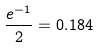Convert formula to latex. <formula><loc_0><loc_0><loc_500><loc_500>\frac { e ^ { - 1 } } { 2 } = 0 . 1 8 4</formula> 